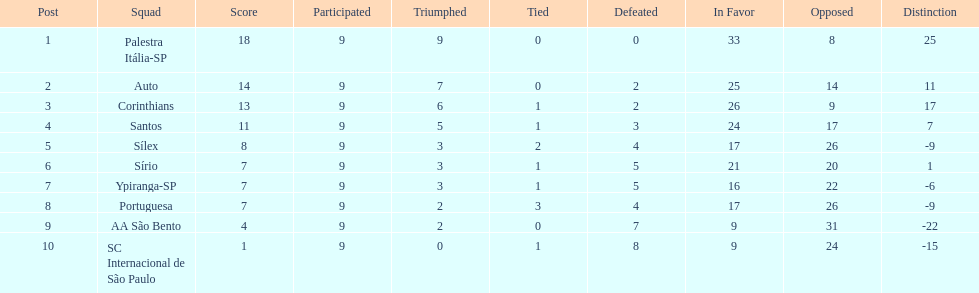Write the full table. {'header': ['Post', 'Squad', 'Score', 'Participated', 'Triumphed', 'Tied', 'Defeated', 'In Favor', 'Opposed', 'Distinction'], 'rows': [['1', 'Palestra Itália-SP', '18', '9', '9', '0', '0', '33', '8', '25'], ['2', 'Auto', '14', '9', '7', '0', '2', '25', '14', '11'], ['3', 'Corinthians', '13', '9', '6', '1', '2', '26', '9', '17'], ['4', 'Santos', '11', '9', '5', '1', '3', '24', '17', '7'], ['5', 'Sílex', '8', '9', '3', '2', '4', '17', '26', '-9'], ['6', 'Sírio', '7', '9', '3', '1', '5', '21', '20', '1'], ['7', 'Ypiranga-SP', '7', '9', '3', '1', '5', '16', '22', '-6'], ['8', 'Portuguesa', '7', '9', '2', '3', '4', '17', '26', '-9'], ['9', 'AA São Bento', '4', '9', '2', '0', '7', '9', '31', '-22'], ['10', 'SC Internacional de São Paulo', '1', '9', '0', '1', '8', '9', '24', '-15']]} During the 1926 brazilian football year, how many teams amassed upwards of 10 points? 4. 